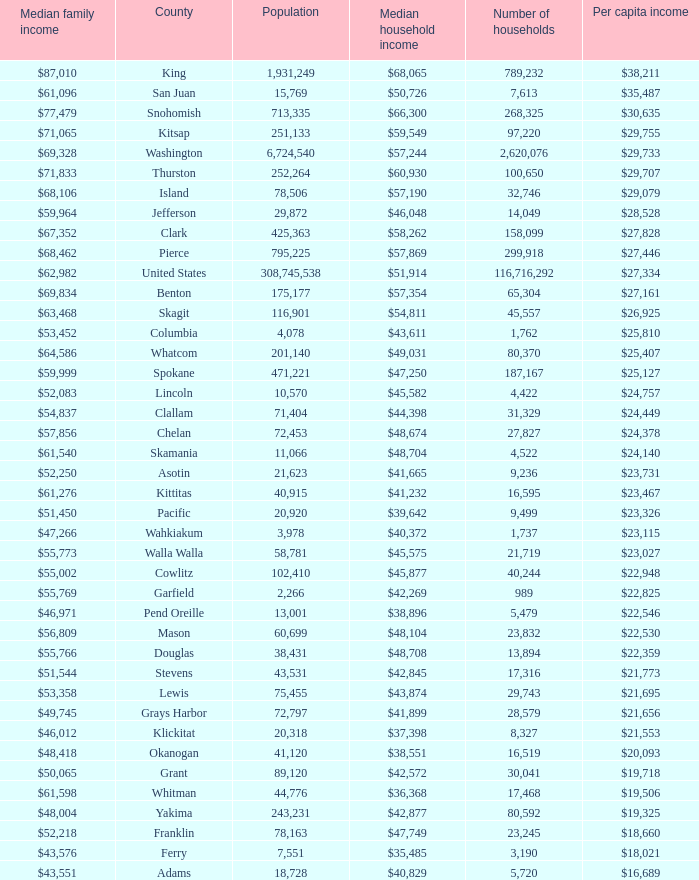How much is per capita income when median household income is $42,845? $21,773. 